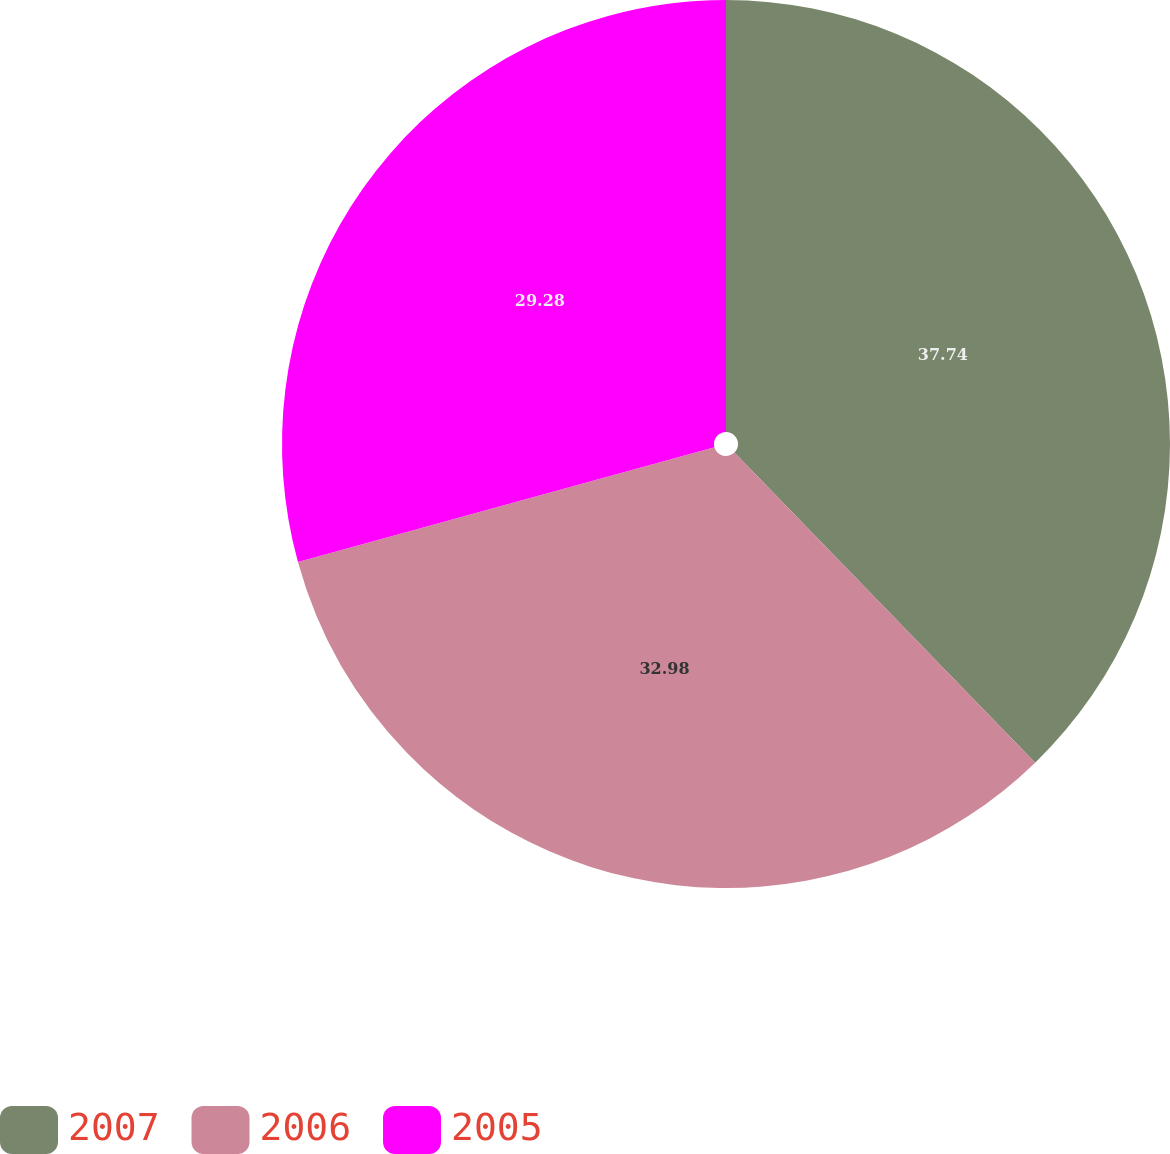<chart> <loc_0><loc_0><loc_500><loc_500><pie_chart><fcel>2007<fcel>2006<fcel>2005<nl><fcel>37.74%<fcel>32.98%<fcel>29.28%<nl></chart> 